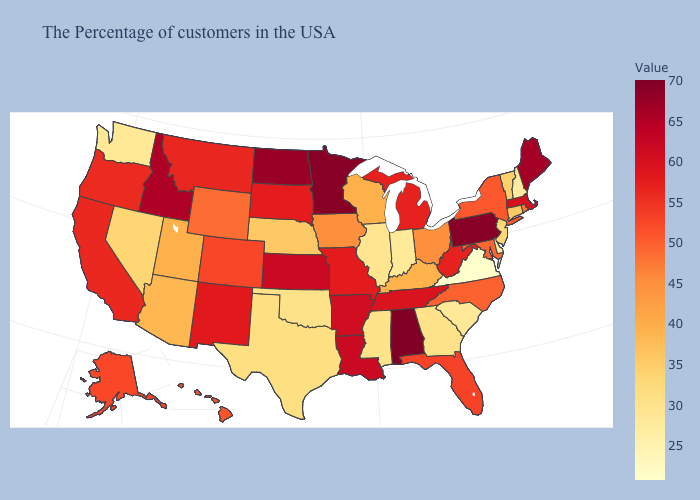Among the states that border New Mexico , does Oklahoma have the lowest value?
Keep it brief. Yes. Among the states that border South Dakota , does Wyoming have the highest value?
Answer briefly. No. Which states have the highest value in the USA?
Give a very brief answer. Alabama. Which states have the highest value in the USA?
Be succinct. Alabama. Among the states that border New York , does Massachusetts have the lowest value?
Keep it brief. No. Does Washington have the lowest value in the West?
Give a very brief answer. Yes. 